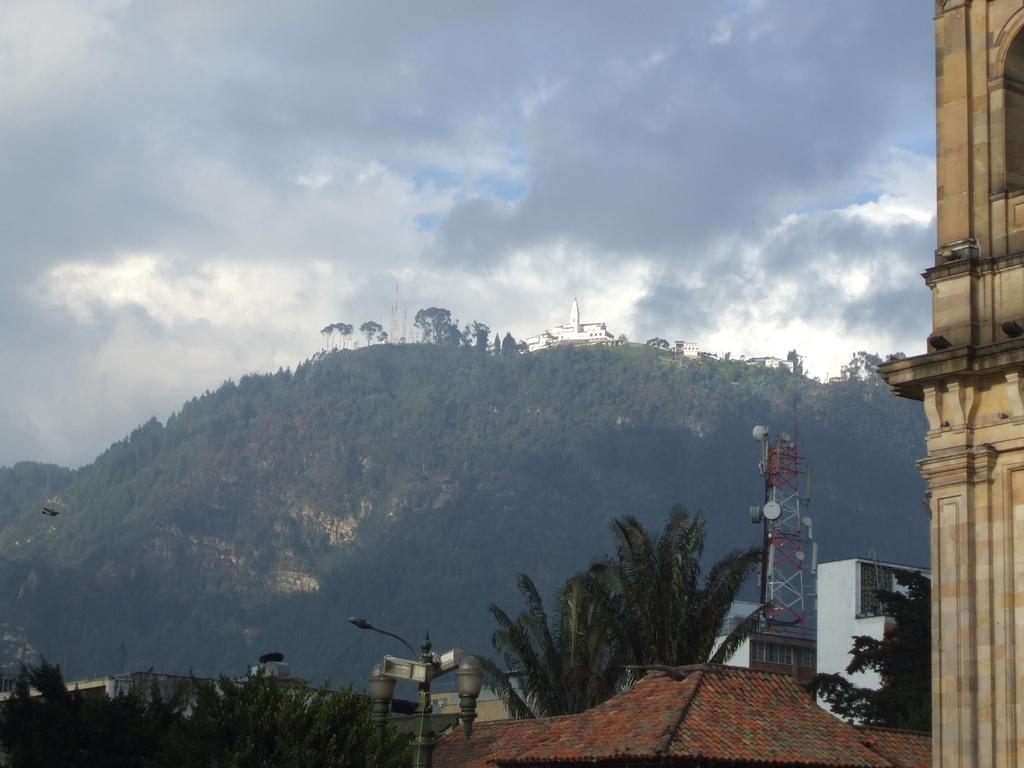What type of structures can be seen in the image? There are buildings, a light pole, and a tower in the image. What other natural elements are present in the image? There are trees and a mountain in the image. What is the condition of the sky in the image? The sky is cloudy in the image. What type of cork can be seen in the image? There is no cork present in the image. What idea is being discussed by the buildings in the image? Buildings do not have the ability to discuss ideas; they are inanimate structures. 